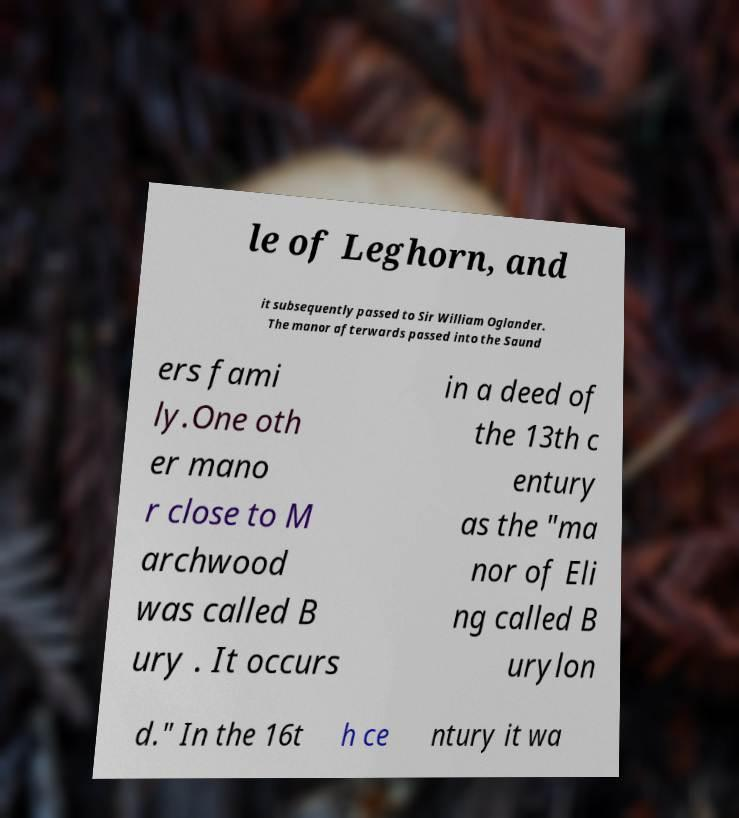There's text embedded in this image that I need extracted. Can you transcribe it verbatim? le of Leghorn, and it subsequently passed to Sir William Oglander. The manor afterwards passed into the Saund ers fami ly.One oth er mano r close to M archwood was called B ury . It occurs in a deed of the 13th c entury as the "ma nor of Eli ng called B urylon d." In the 16t h ce ntury it wa 